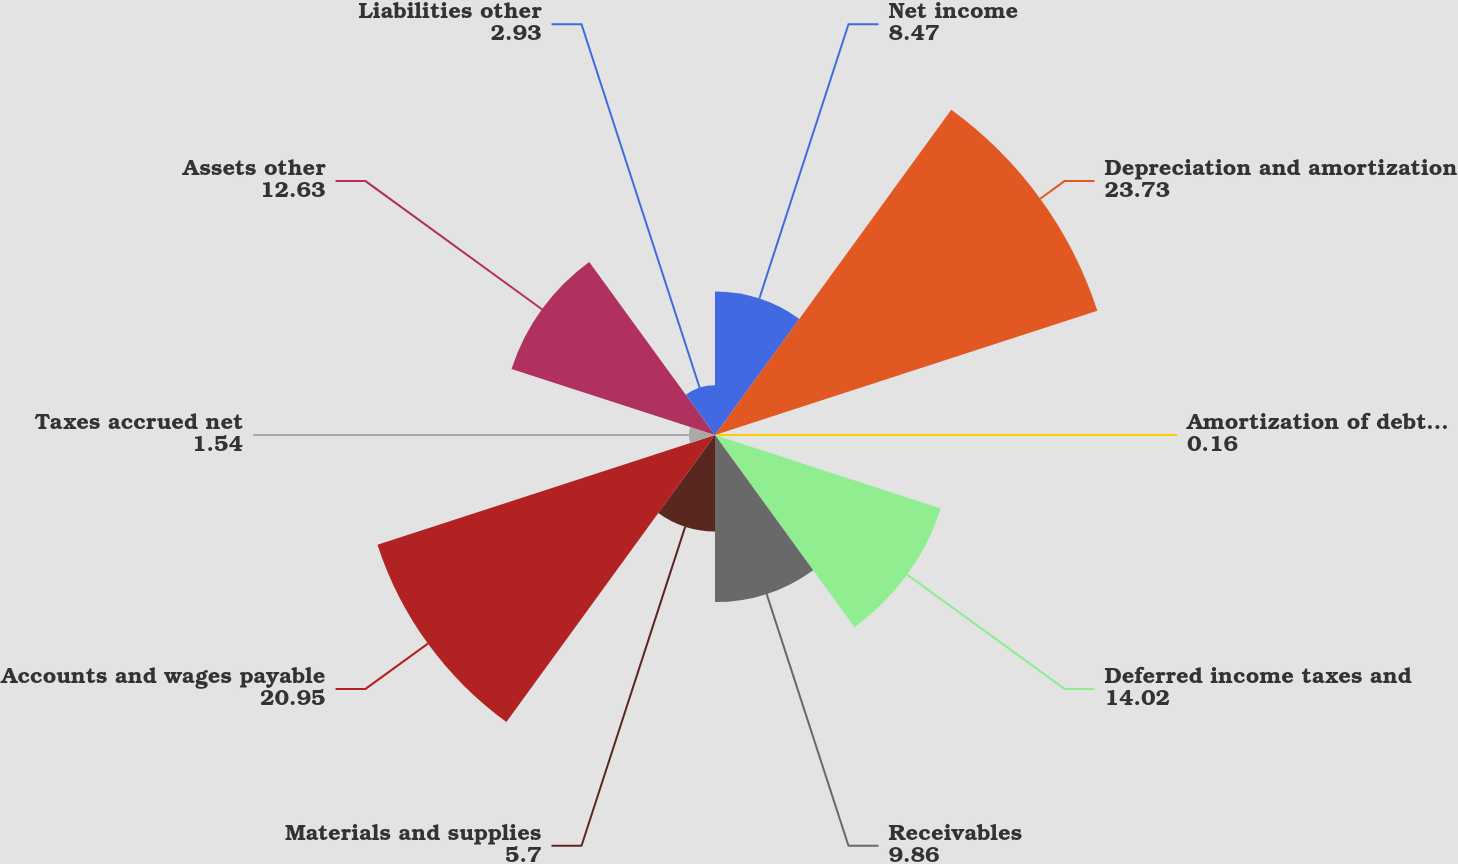Convert chart. <chart><loc_0><loc_0><loc_500><loc_500><pie_chart><fcel>Net income<fcel>Depreciation and amortization<fcel>Amortization of debt issuance<fcel>Deferred income taxes and<fcel>Receivables<fcel>Materials and supplies<fcel>Accounts and wages payable<fcel>Taxes accrued net<fcel>Assets other<fcel>Liabilities other<nl><fcel>8.47%<fcel>23.73%<fcel>0.16%<fcel>14.02%<fcel>9.86%<fcel>5.7%<fcel>20.95%<fcel>1.54%<fcel>12.63%<fcel>2.93%<nl></chart> 